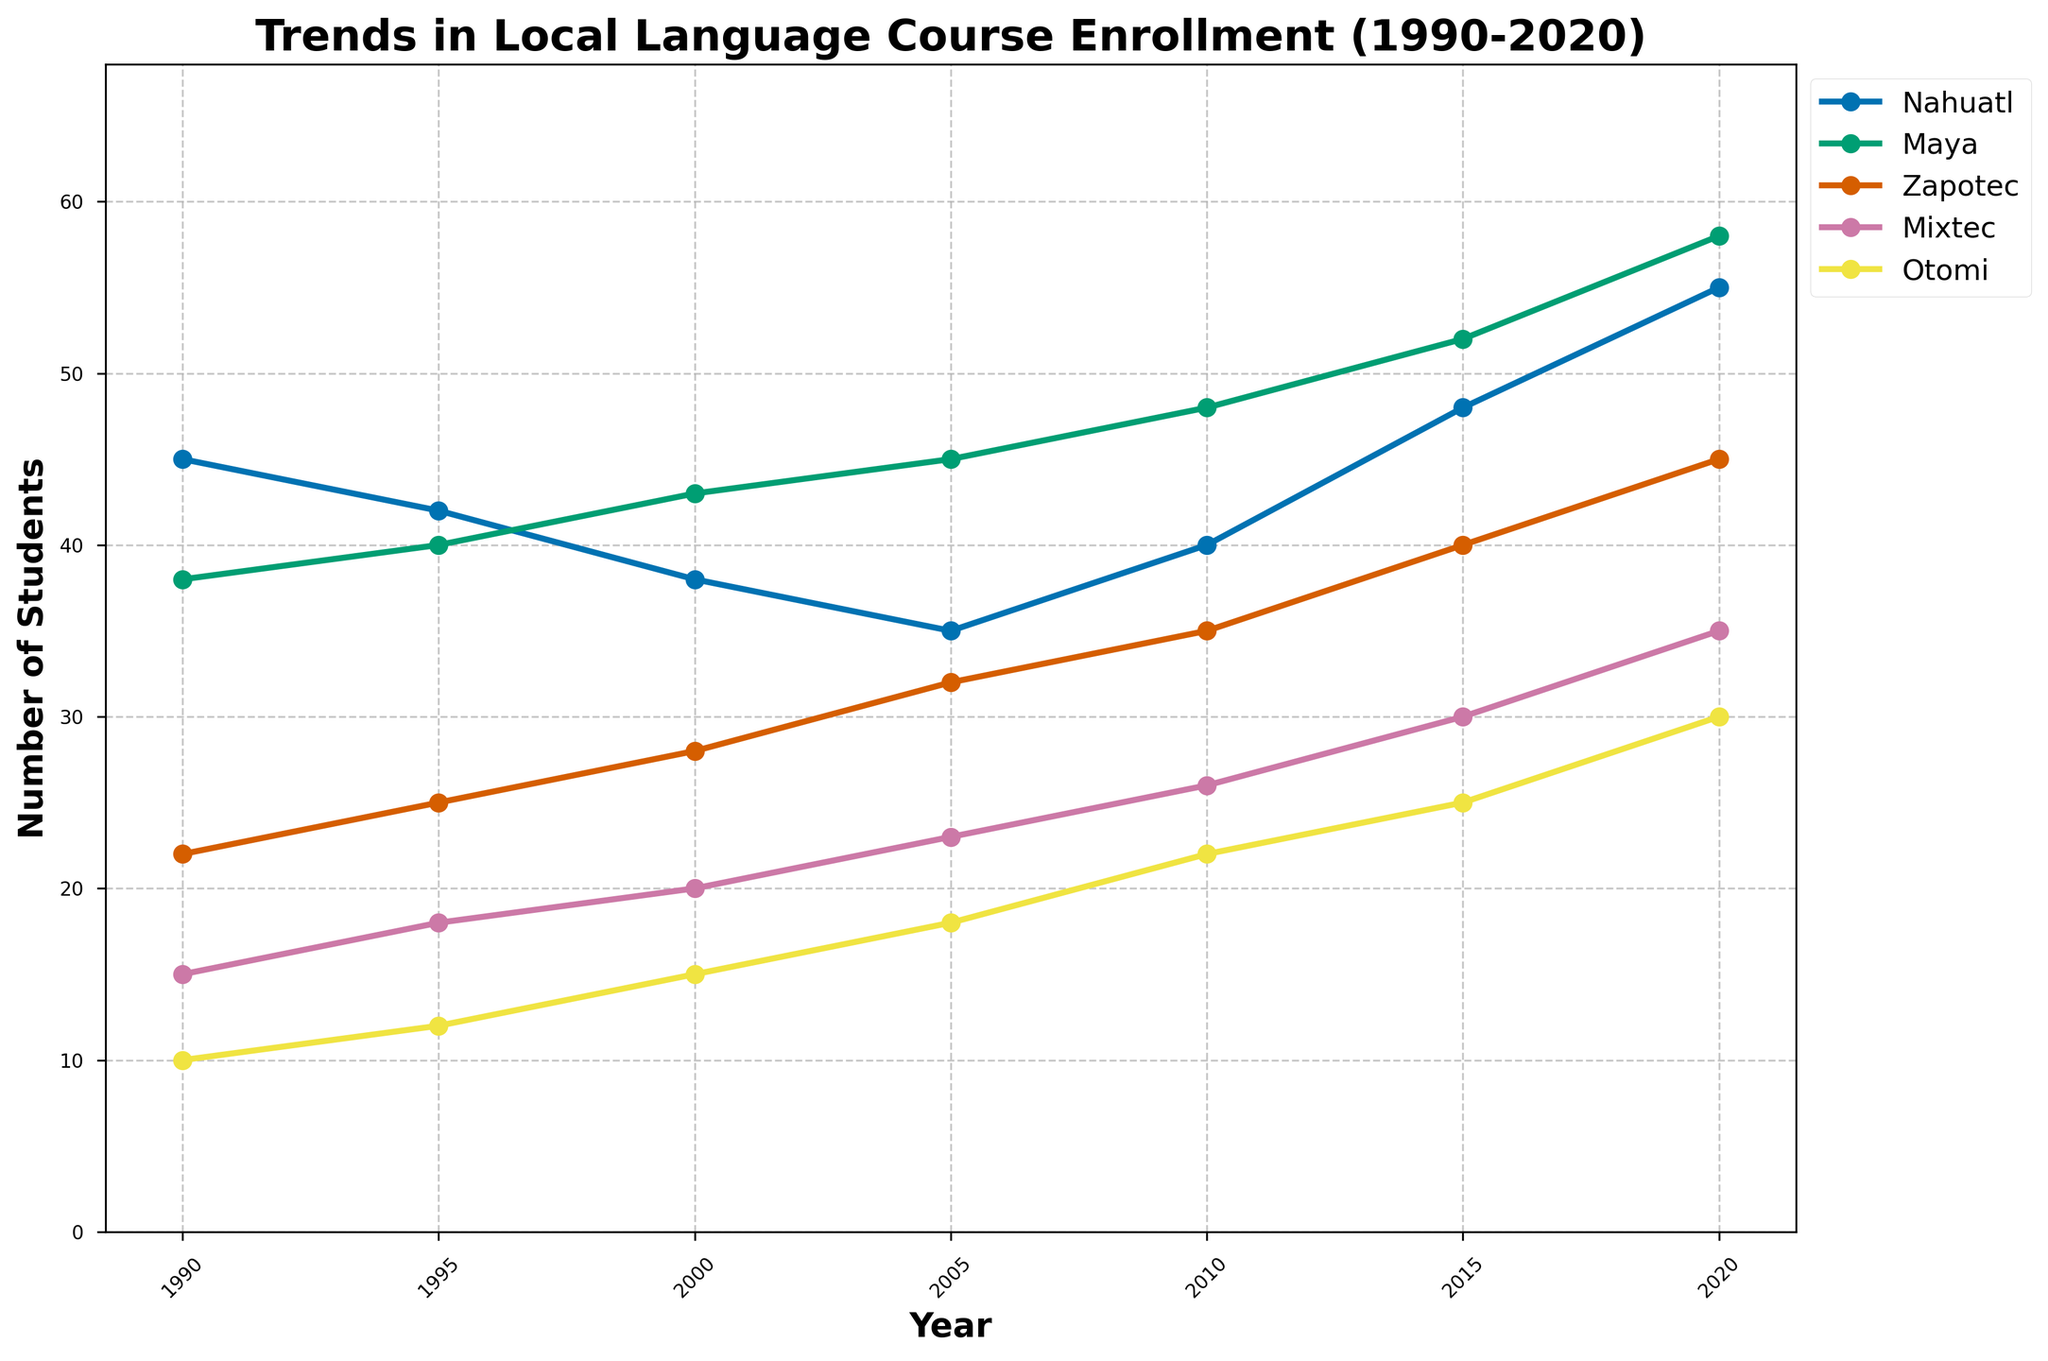How did the number of students enrolled in Nahuatl courses change from 1990 to 2020? To answer this, identify the number of students in 1990 and 2020 from the Nahuatl line. In 1990, the number of students enrolled is 45, and in 2020, it is 55. The change is calculated as 55 - 45 = 10.
Answer: The enrollment increased by 10 students Which language had the highest enrollment in 2020? Look at the endpoints of all the lines representing different languages in the year 2020. The highest endpoint corresponds to Maya, which enrolled 58 students.
Answer: Maya By how much did the enrollment in Mixtec courses increase between 2005 and 2015? Find the values at 2005 and 2015 for Mixtec by examining the Mixtec line. In 2005, it was 23, and in 2015, it was 30. The increase is calculated as 30 - 23 = 7.
Answer: 7 Which language had the smallest increase in the number of students from 1990 to 2020? Calculate the difference between the values in 2020 and 1990 for each language. The increases are: 
Nahuatl: 55 - 45 = 10 
Maya: 58 - 38 = 20 
Zapotec: 45 - 22 = 23 
Mixtec: 35 - 15 = 20 
Otomi: 30 - 10 = 20
The smallest increase is for Nahuatl.
Answer: Nahuatl In which year did the Otomi courses see the highest student enrollment? Find the highest point on the Otomi line and note the corresponding year. The highest enrollment for Otomi is at the endpoint of the line in 2020, with 30 students.
Answer: 2020 What is the average number of students enrolled in Maya courses from 1990 to 2020? Sum the number of students from Maya courses across all years and divide by the number of years. Sum: 38 + 40 + 43 + 45 + 48 + 52 + 58 = 324. Number of years: 7. The average is 324 / 7 = 46.29.
Answer: 46.29 Which language had the highest growth rate between 1995 and 2005? Calculate the growth rate for each language between 1995 and 2005 using the formula (value in 2005 - value in 1995) / (value in 1995) * 100%.
Growth rates:
Nahuatl: (35 - 42) / 42 * 100% = -16.67%
Maya: (45 - 40) / 40 * 100% = 12.5%
Zapotec: (32 - 25) / 25 * 100% = 28%
Mixtec: (23 - 18) / 18 * 100% = 27.78%
Otomi: (18 - 12) / 12 * 100% = 50%
The highest growth rate is for Otomi.
Answer: Otomi What is the combined enrollment for all languages in the year 2010? Add the enrollment numbers for all the languages in 2010. Nahuatl: 40, Maya: 48, Zapotec: 35, Mixtec: 26, Otomi: 22. The combined enrollment is 40 + 48 + 35 + 26 + 22 = 171.
Answer: 171 